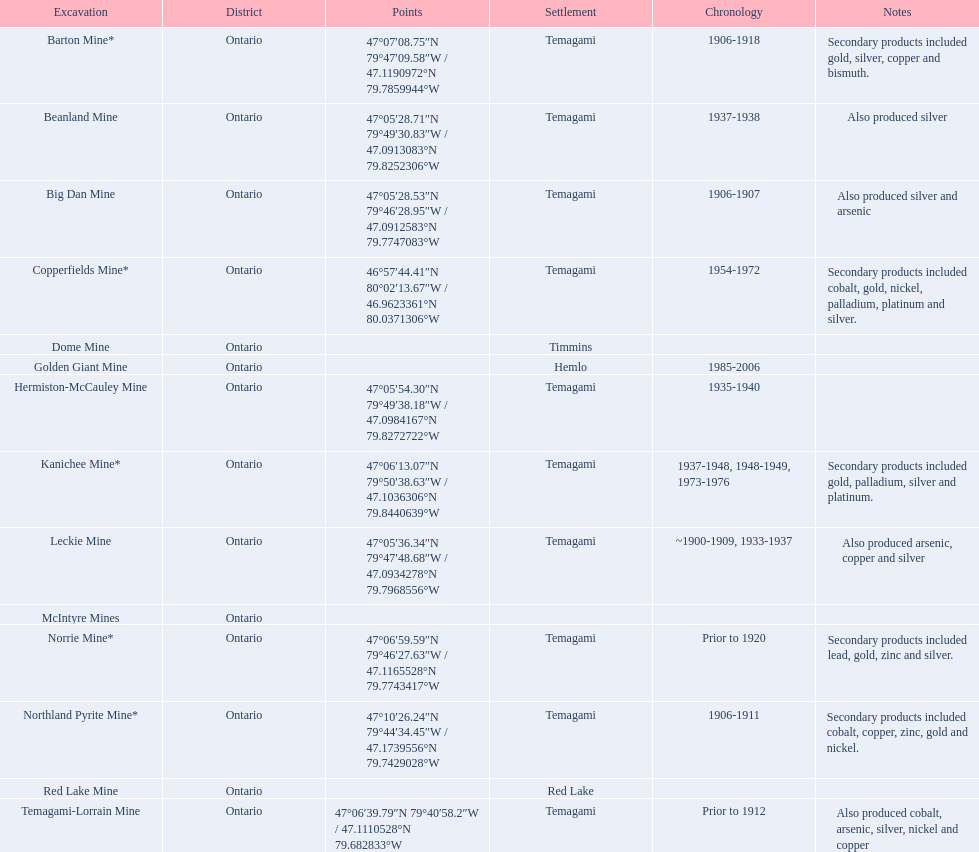Tell me the number of mines that also produced arsenic. 3. 